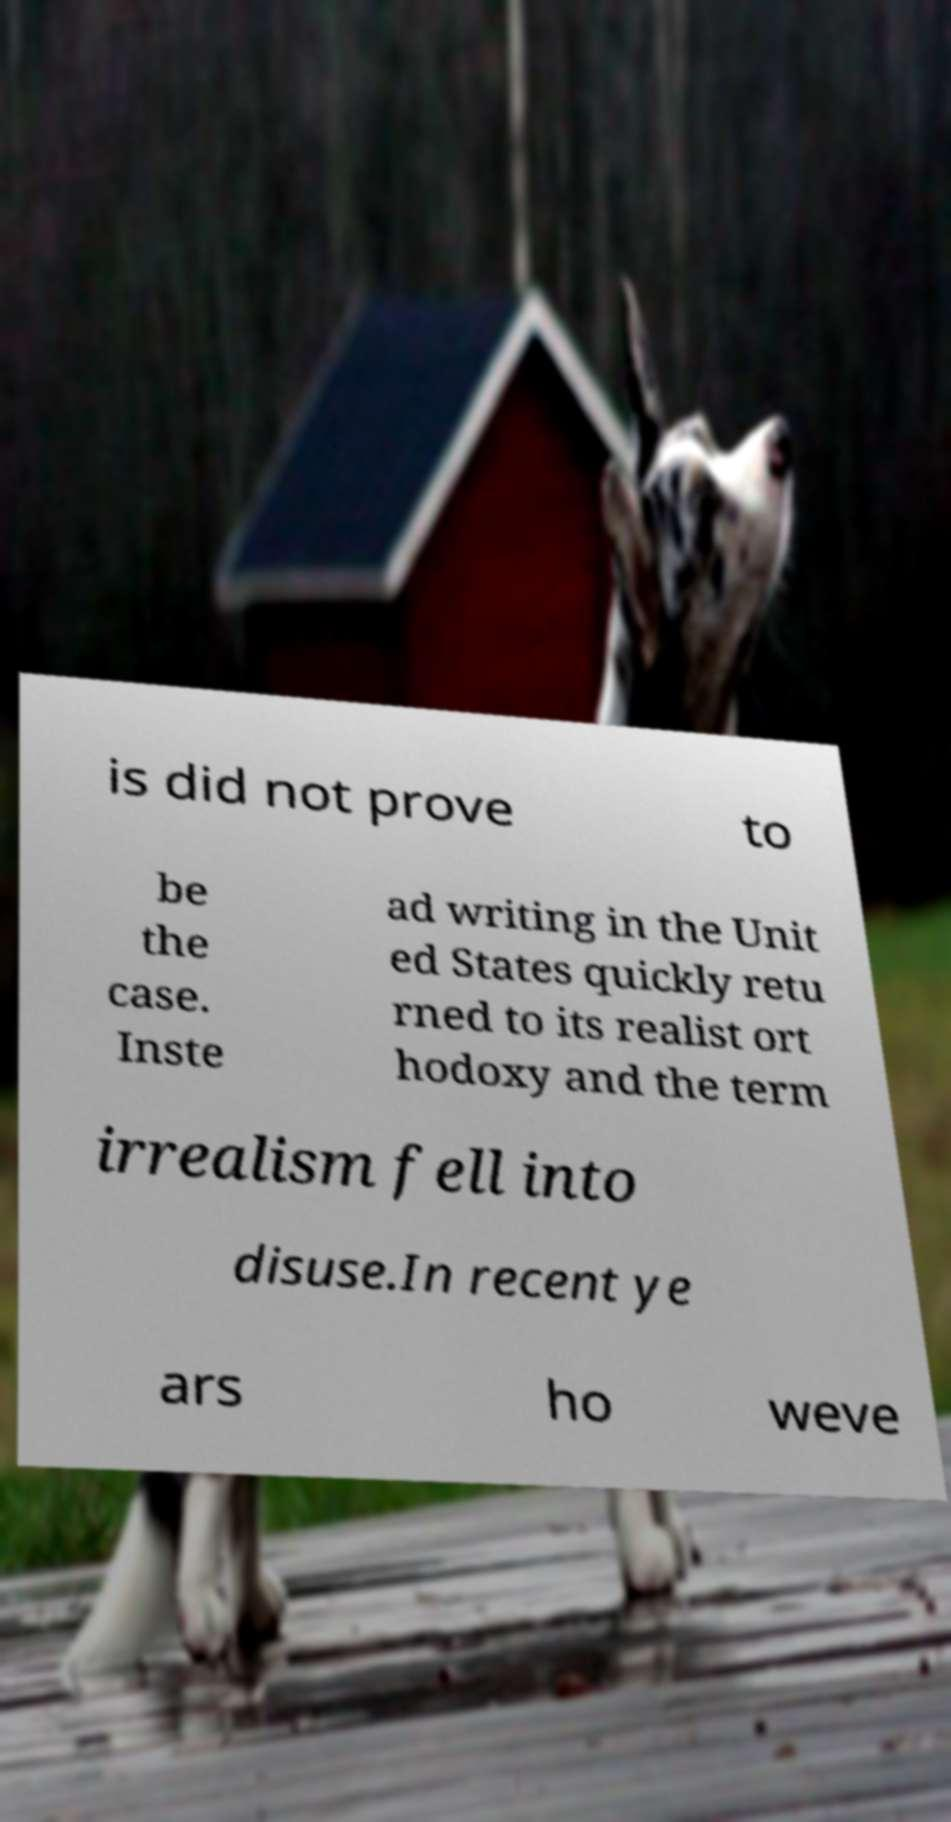For documentation purposes, I need the text within this image transcribed. Could you provide that? is did not prove to be the case. Inste ad writing in the Unit ed States quickly retu rned to its realist ort hodoxy and the term irrealism fell into disuse.In recent ye ars ho weve 